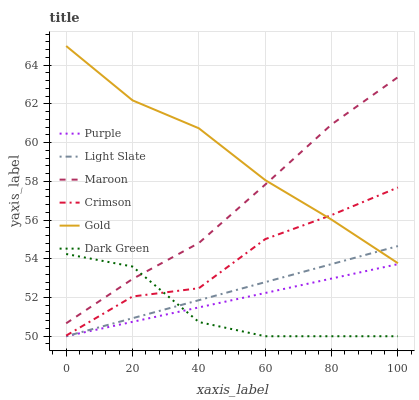Does Dark Green have the minimum area under the curve?
Answer yes or no. Yes. Does Gold have the maximum area under the curve?
Answer yes or no. Yes. Does Purple have the minimum area under the curve?
Answer yes or no. No. Does Purple have the maximum area under the curve?
Answer yes or no. No. Is Purple the smoothest?
Answer yes or no. Yes. Is Crimson the roughest?
Answer yes or no. Yes. Is Maroon the smoothest?
Answer yes or no. No. Is Maroon the roughest?
Answer yes or no. No. Does Maroon have the lowest value?
Answer yes or no. No. Does Maroon have the highest value?
Answer yes or no. No. Is Light Slate less than Maroon?
Answer yes or no. Yes. Is Maroon greater than Light Slate?
Answer yes or no. Yes. Does Light Slate intersect Maroon?
Answer yes or no. No. 